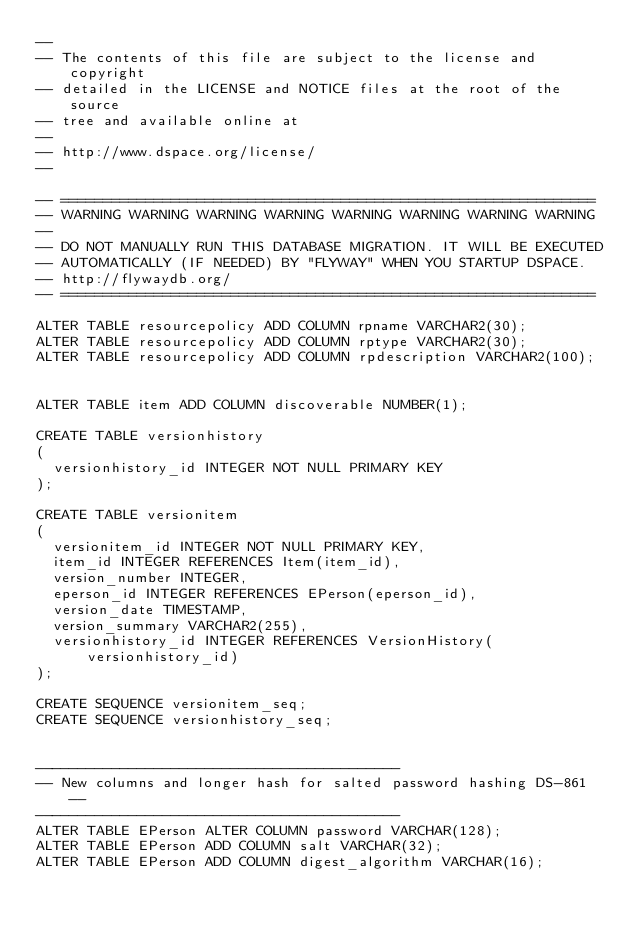<code> <loc_0><loc_0><loc_500><loc_500><_SQL_>--
-- The contents of this file are subject to the license and copyright
-- detailed in the LICENSE and NOTICE files at the root of the source
-- tree and available online at
--
-- http://www.dspace.org/license/
--

-- ===============================================================
-- WARNING WARNING WARNING WARNING WARNING WARNING WARNING WARNING
--
-- DO NOT MANUALLY RUN THIS DATABASE MIGRATION. IT WILL BE EXECUTED
-- AUTOMATICALLY (IF NEEDED) BY "FLYWAY" WHEN YOU STARTUP DSPACE.
-- http://flywaydb.org/
-- ===============================================================

ALTER TABLE resourcepolicy ADD COLUMN rpname VARCHAR2(30);
ALTER TABLE resourcepolicy ADD COLUMN rptype VARCHAR2(30);
ALTER TABLE resourcepolicy ADD COLUMN rpdescription VARCHAR2(100);


ALTER TABLE item ADD COLUMN discoverable NUMBER(1);

CREATE TABLE versionhistory
(
  versionhistory_id INTEGER NOT NULL PRIMARY KEY
);

CREATE TABLE versionitem
(
  versionitem_id INTEGER NOT NULL PRIMARY KEY,
  item_id INTEGER REFERENCES Item(item_id),
  version_number INTEGER,
  eperson_id INTEGER REFERENCES EPerson(eperson_id),
  version_date TIMESTAMP,
  version_summary VARCHAR2(255),
  versionhistory_id INTEGER REFERENCES VersionHistory(versionhistory_id)
);

CREATE SEQUENCE versionitem_seq;
CREATE SEQUENCE versionhistory_seq;


-------------------------------------------
-- New columns and longer hash for salted password hashing DS-861 --
-------------------------------------------
ALTER TABLE EPerson ALTER COLUMN password VARCHAR(128);
ALTER TABLE EPerson ADD COLUMN salt VARCHAR(32);
ALTER TABLE EPerson ADD COLUMN digest_algorithm VARCHAR(16);
</code> 